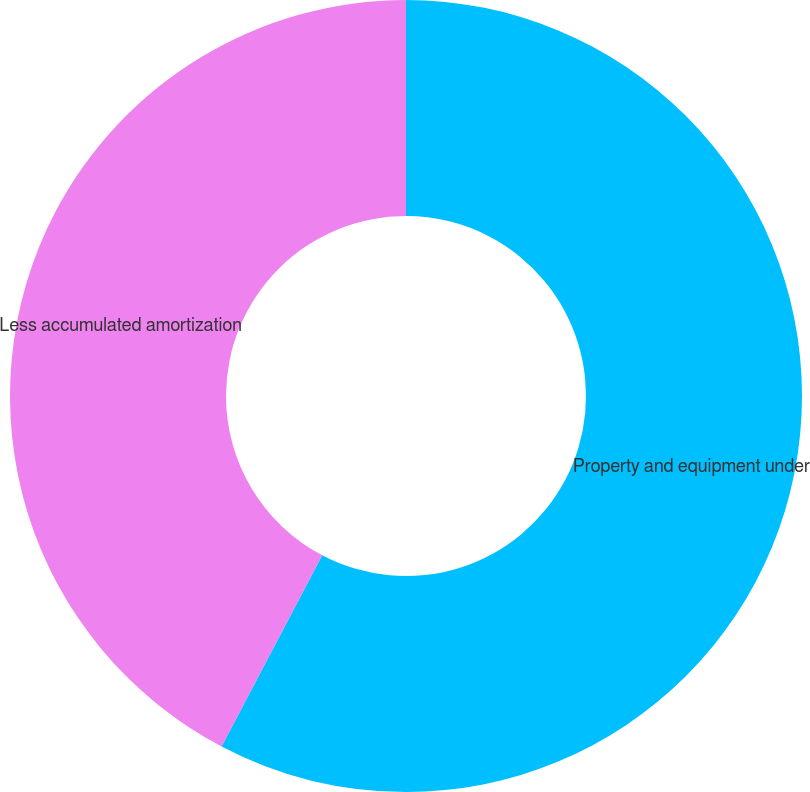<chart> <loc_0><loc_0><loc_500><loc_500><pie_chart><fcel>Property and equipment under<fcel>Less accumulated amortization<nl><fcel>57.71%<fcel>42.29%<nl></chart> 